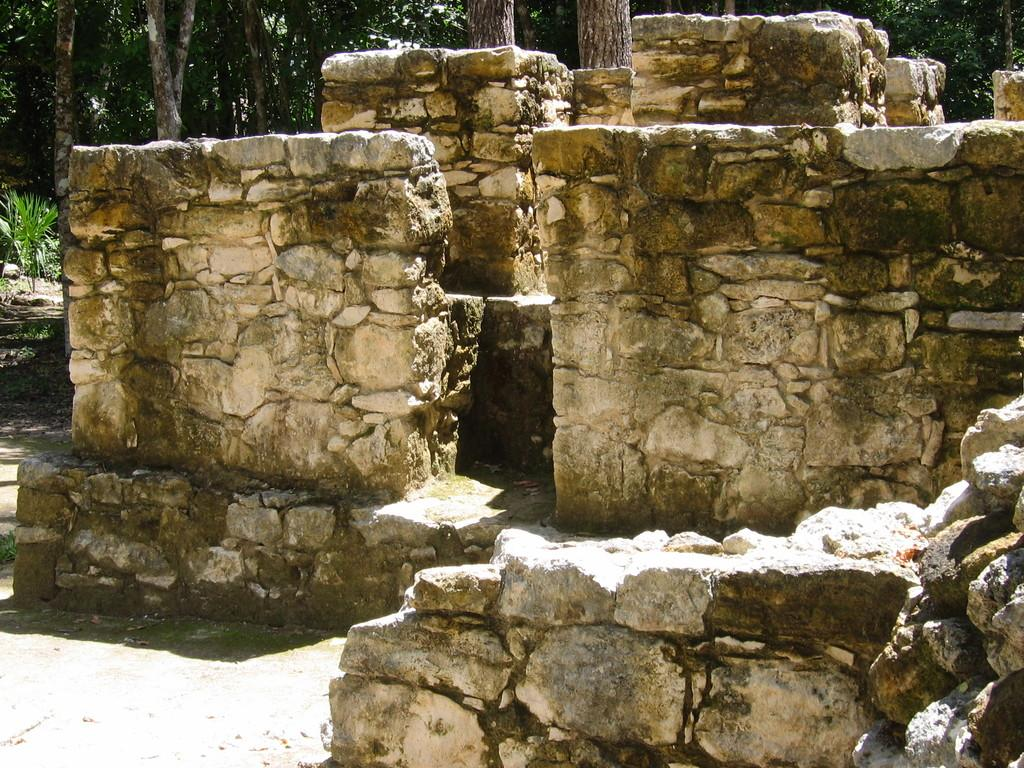What type of structures can be seen in the image? There are walls in the image. What can be found in the middle of the image? There is a walkway in the image. What type of natural elements are visible in the background of the image? There are trees and tree trunks visible in the background of the image. What type of vegetation is on the left side of the image? There are plants and grass present on the left side of the image. What type of war is being depicted in the image? There is no war depicted in the image; it features walls, a walkway, trees, tree trunks, plants, and grass. How does the disgust in the image manifest itself? There is no indication of disgust in the image; it is a peaceful scene with natural elements and structures. 